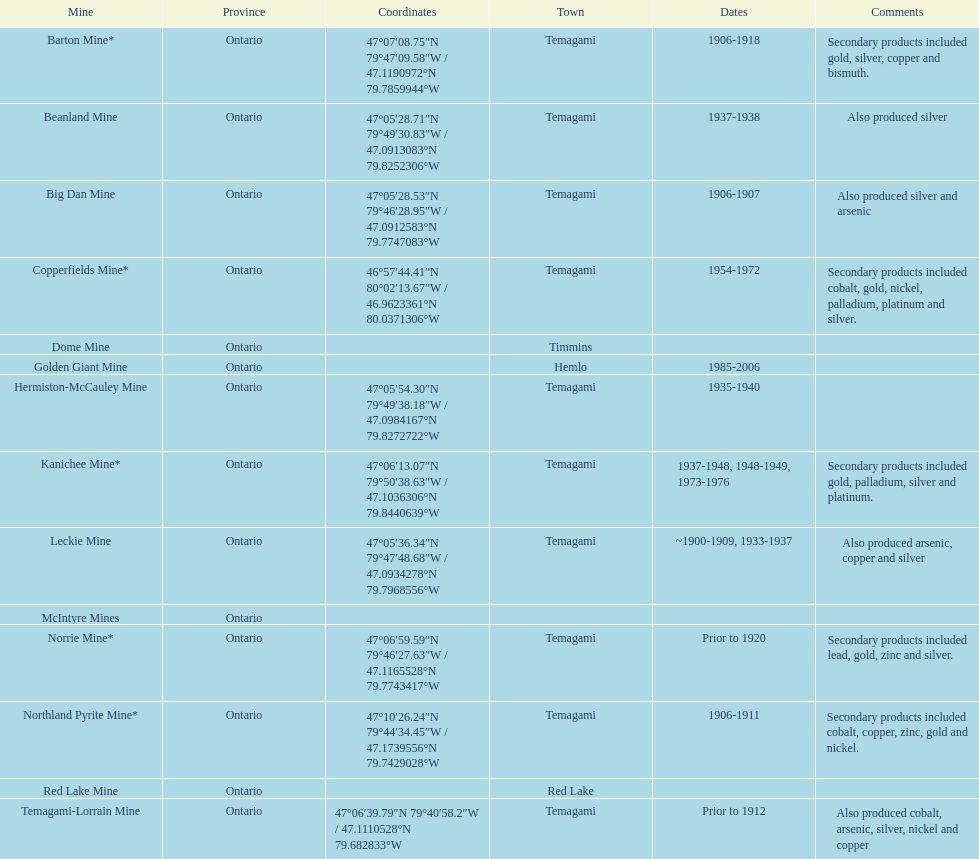How many occurrences of temagami are there on the list? 10. 